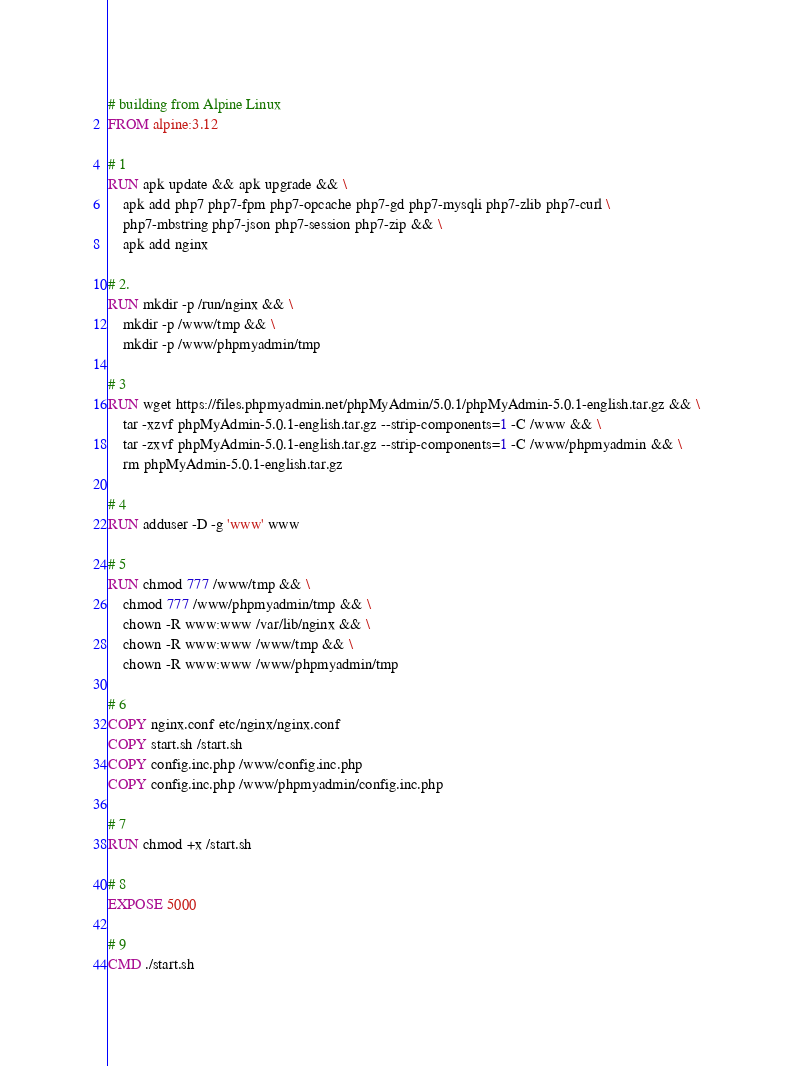<code> <loc_0><loc_0><loc_500><loc_500><_Dockerfile_># building from Alpine Linux
FROM alpine:3.12

# 1
RUN apk update && apk upgrade && \
	apk add php7 php7-fpm php7-opcache php7-gd php7-mysqli php7-zlib php7-curl \
	php7-mbstring php7-json php7-session php7-zip && \
	apk add nginx

# 2.
RUN mkdir -p /run/nginx && \
	mkdir -p /www/tmp && \
	mkdir -p /www/phpmyadmin/tmp

# 3
RUN wget https://files.phpmyadmin.net/phpMyAdmin/5.0.1/phpMyAdmin-5.0.1-english.tar.gz && \
	tar -xzvf phpMyAdmin-5.0.1-english.tar.gz --strip-components=1 -C /www && \
	tar -zxvf phpMyAdmin-5.0.1-english.tar.gz --strip-components=1 -C /www/phpmyadmin && \
	rm phpMyAdmin-5.0.1-english.tar.gz

# 4
RUN adduser -D -g 'www' www

# 5
RUN chmod 777 /www/tmp && \
	chmod 777 /www/phpmyadmin/tmp && \
	chown -R www:www /var/lib/nginx && \		
	chown -R www:www /www/tmp && \
	chown -R www:www /www/phpmyadmin/tmp

# 6
COPY nginx.conf etc/nginx/nginx.conf
COPY start.sh /start.sh
COPY config.inc.php /www/config.inc.php
COPY config.inc.php /www/phpmyadmin/config.inc.php

# 7
RUN chmod +x /start.sh

# 8
EXPOSE 5000

# 9
CMD ./start.sh
</code> 